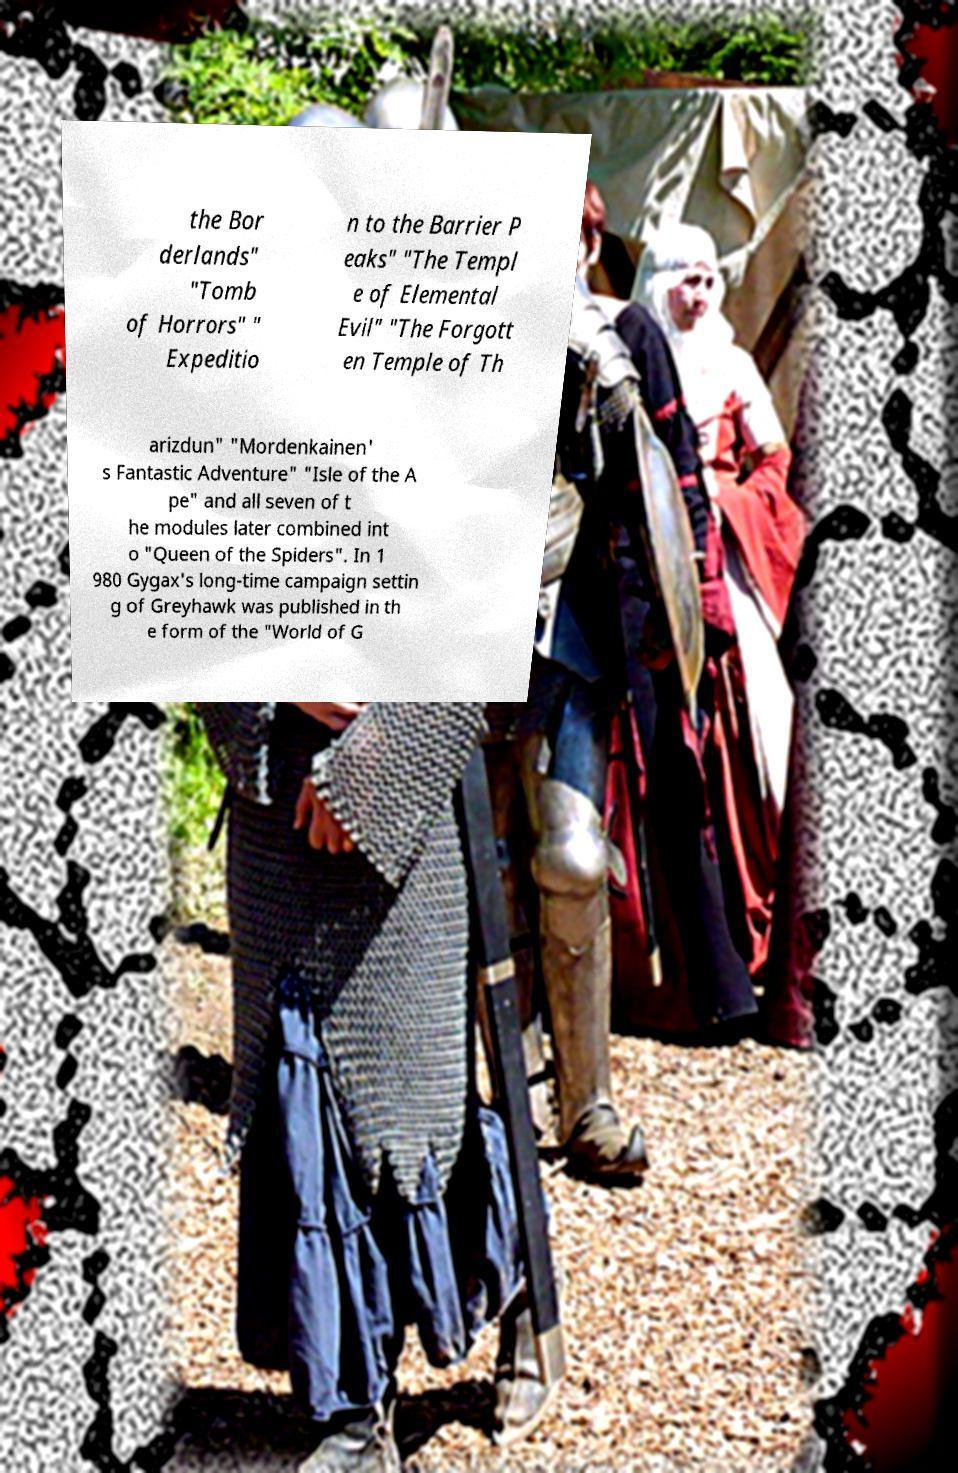I need the written content from this picture converted into text. Can you do that? the Bor derlands" "Tomb of Horrors" " Expeditio n to the Barrier P eaks" "The Templ e of Elemental Evil" "The Forgott en Temple of Th arizdun" "Mordenkainen' s Fantastic Adventure" "Isle of the A pe" and all seven of t he modules later combined int o "Queen of the Spiders". In 1 980 Gygax's long-time campaign settin g of Greyhawk was published in th e form of the "World of G 